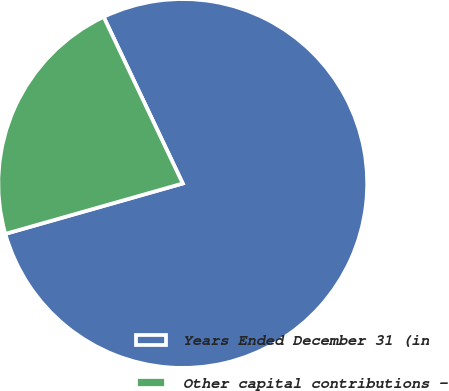Convert chart. <chart><loc_0><loc_0><loc_500><loc_500><pie_chart><fcel>Years Ended December 31 (in<fcel>Other capital contributions -<nl><fcel>77.65%<fcel>22.35%<nl></chart> 